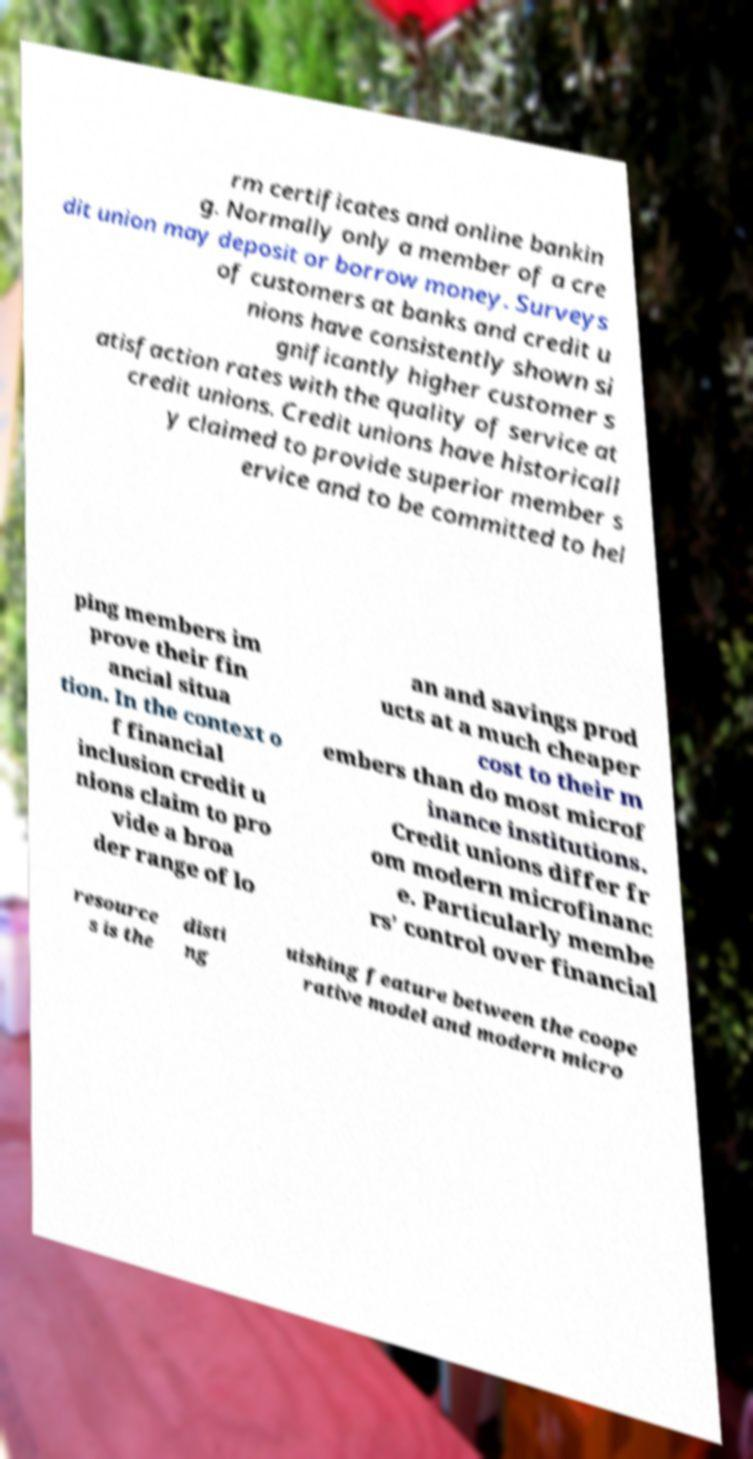Can you read and provide the text displayed in the image?This photo seems to have some interesting text. Can you extract and type it out for me? rm certificates and online bankin g. Normally only a member of a cre dit union may deposit or borrow money. Surveys of customers at banks and credit u nions have consistently shown si gnificantly higher customer s atisfaction rates with the quality of service at credit unions. Credit unions have historicall y claimed to provide superior member s ervice and to be committed to hel ping members im prove their fin ancial situa tion. In the context o f financial inclusion credit u nions claim to pro vide a broa der range of lo an and savings prod ucts at a much cheaper cost to their m embers than do most microf inance institutions. Credit unions differ fr om modern microfinanc e. Particularly membe rs’ control over financial resource s is the disti ng uishing feature between the coope rative model and modern micro 